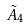<formula> <loc_0><loc_0><loc_500><loc_500>\tilde { A } _ { 4 }</formula> 